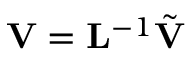Convert formula to latex. <formula><loc_0><loc_0><loc_500><loc_500>{ V } = { L } ^ { - 1 } \tilde { V }</formula> 